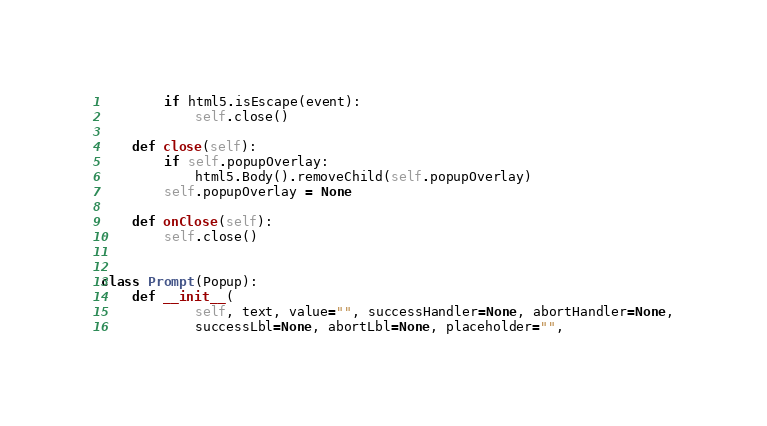Convert code to text. <code><loc_0><loc_0><loc_500><loc_500><_Python_>		if html5.isEscape(event):
			self.close()

	def close(self):
		if self.popupOverlay:
			html5.Body().removeChild(self.popupOverlay)
		self.popupOverlay = None

	def onClose(self):
		self.close()


class Prompt(Popup):
	def __init__(
			self, text, value="", successHandler=None, abortHandler=None,
			successLbl=None, abortLbl=None, placeholder="",</code> 